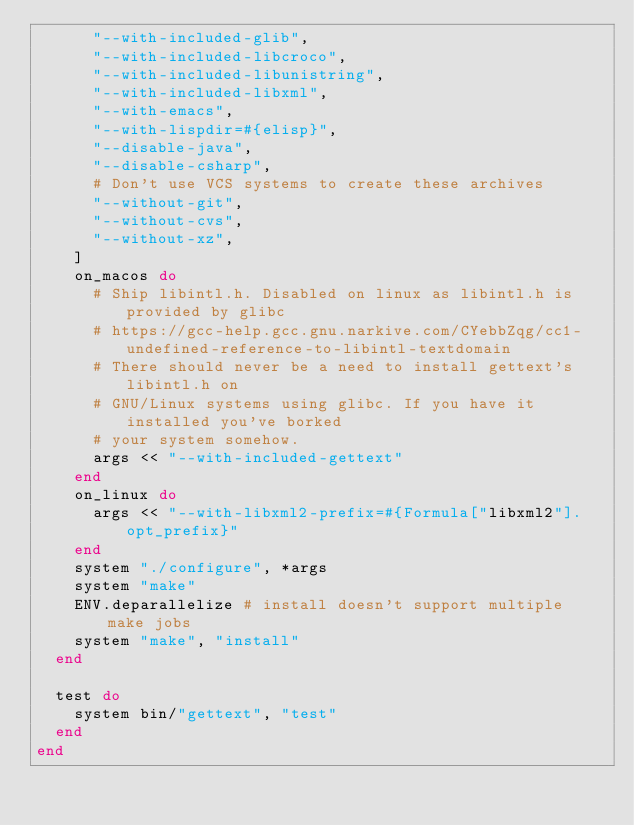Convert code to text. <code><loc_0><loc_0><loc_500><loc_500><_Ruby_>      "--with-included-glib",
      "--with-included-libcroco",
      "--with-included-libunistring",
      "--with-included-libxml",
      "--with-emacs",
      "--with-lispdir=#{elisp}",
      "--disable-java",
      "--disable-csharp",
      # Don't use VCS systems to create these archives
      "--without-git",
      "--without-cvs",
      "--without-xz",
    ]
    on_macos do
      # Ship libintl.h. Disabled on linux as libintl.h is provided by glibc
      # https://gcc-help.gcc.gnu.narkive.com/CYebbZqg/cc1-undefined-reference-to-libintl-textdomain
      # There should never be a need to install gettext's libintl.h on
      # GNU/Linux systems using glibc. If you have it installed you've borked
      # your system somehow.
      args << "--with-included-gettext"
    end
    on_linux do
      args << "--with-libxml2-prefix=#{Formula["libxml2"].opt_prefix}"
    end
    system "./configure", *args
    system "make"
    ENV.deparallelize # install doesn't support multiple make jobs
    system "make", "install"
  end

  test do
    system bin/"gettext", "test"
  end
end
</code> 